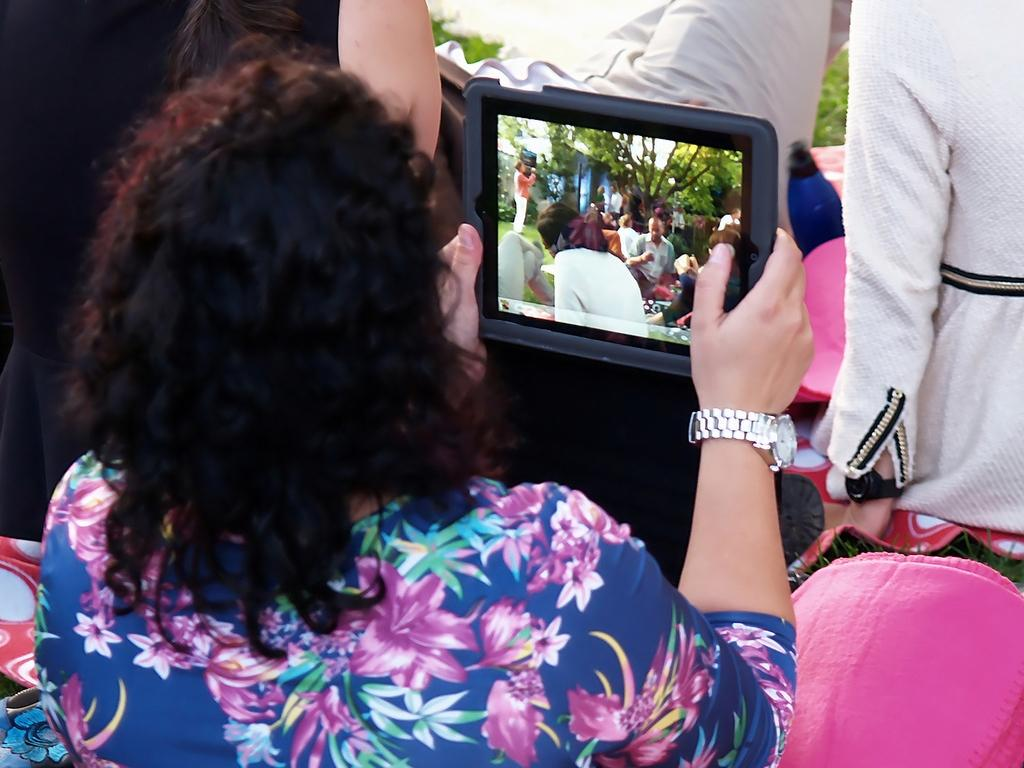What is the main subject of the image? There is a woman in the image. What is the woman holding in her hand? The woman is holding an object in her hand. Can you describe any accessories the woman is wearing? The woman is wearing a watch on her hand. What can be seen on the screen in the image? People and trees are visible on the screen. What type of riddle is the woman trying to solve in the image? There is no riddle present in the image; the woman is simply holding an object and wearing a watch. What is the name of the truck visible on the screen? There is no truck visible on the screen; only people and trees can be seen. 